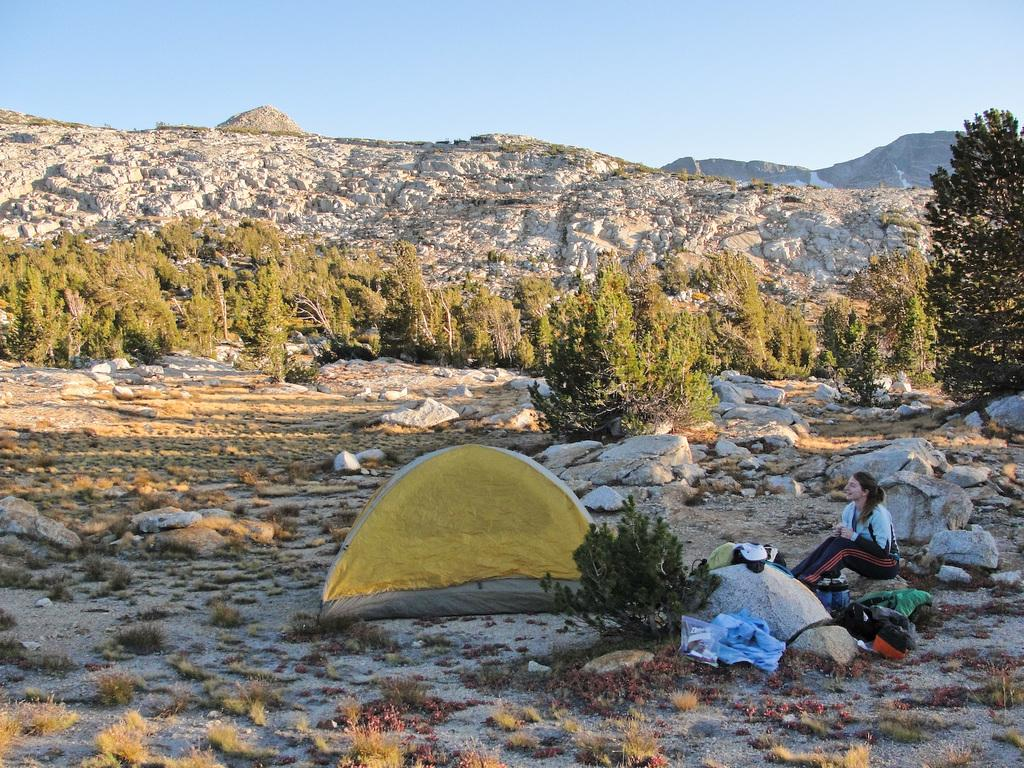What is the woman in the image doing? The woman is sitting on a rock in the image. What items related to clothing can be seen in the image? Clothes are present in the image. What type of shelter is visible in the image? There is a tent in the image. What type of natural vegetation is present in the image? Plants are visible in the image. What type of geological formation is present in the image? Rocks are present in the image. What type of natural landscape can be seen in the background of the image? Trees and mountains are visible in the background of the image. What part of the natural environment is visible in the background of the image? The sky is visible in the background of the image. How many cows are grazing in the image? There are no cows present in the image. What type of door can be seen in the image? There is no door present in the image. 